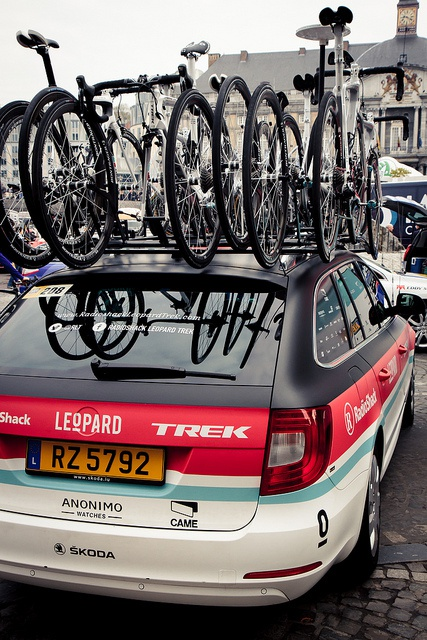Describe the objects in this image and their specific colors. I can see car in white, black, darkgray, gray, and lightgray tones, bicycle in white, black, darkgray, gray, and lightgray tones, bicycle in white, black, gray, darkgray, and lightgray tones, bicycle in white, black, darkgray, and gray tones, and bicycle in white, black, gray, darkgray, and lightgray tones in this image. 